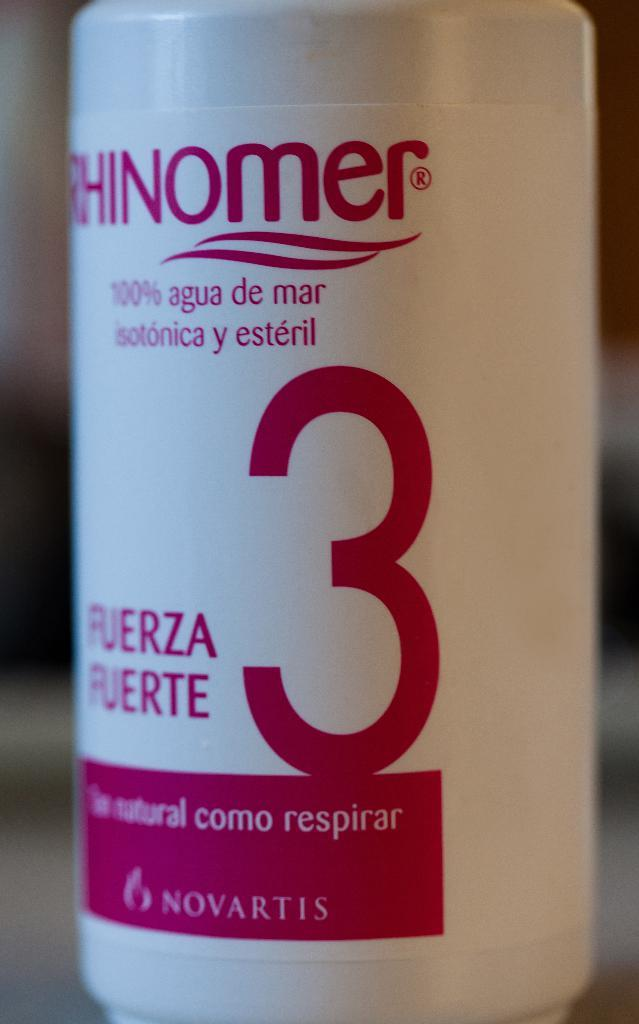<image>
Present a compact description of the photo's key features. a red and white bottle with the number 3 on it 